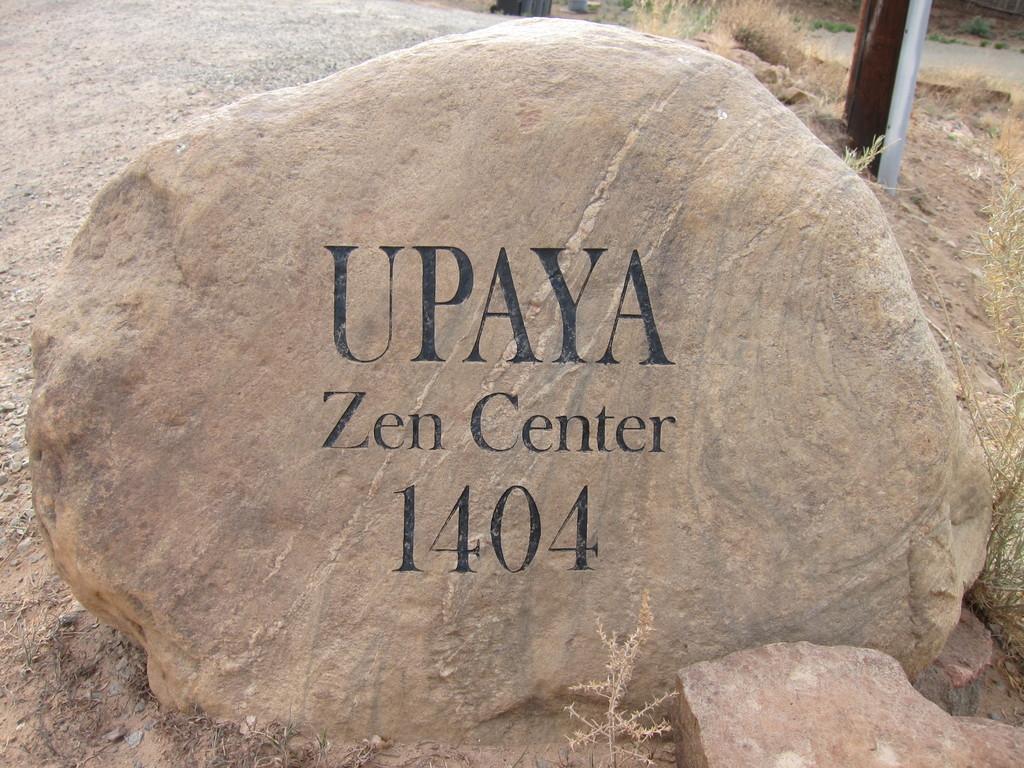In one or two sentences, can you explain what this image depicts? In this image I can see a rock, text, grass and a road. This image is taken during a day. 